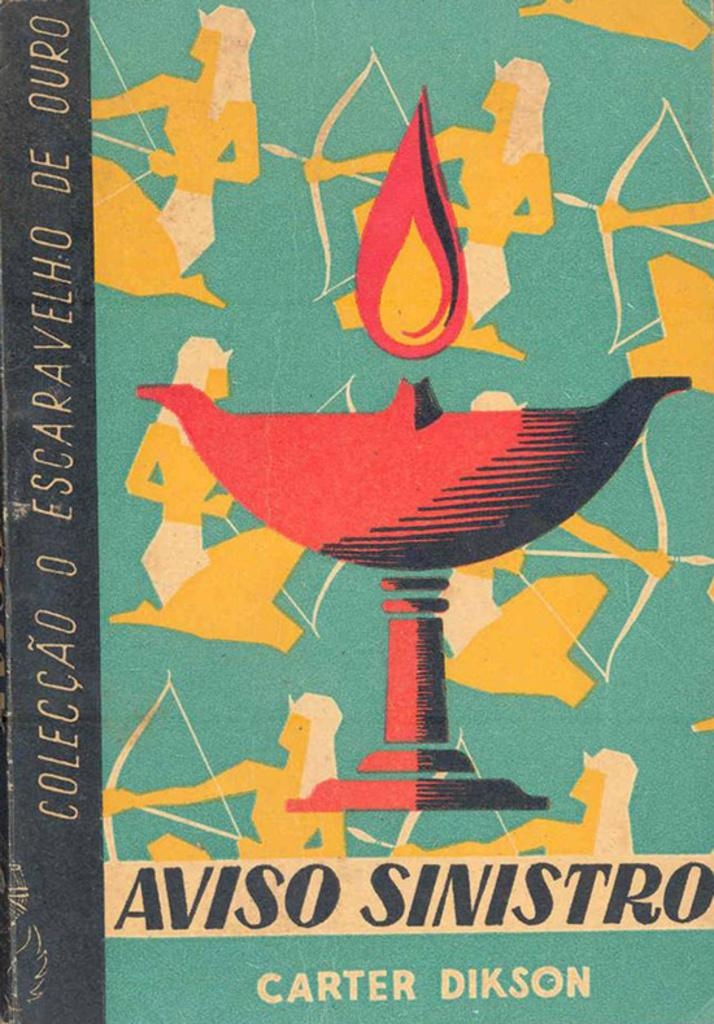<image>
Present a compact description of the photo's key features. A book called Aviso Sinistro is written by Carter Dikson. 